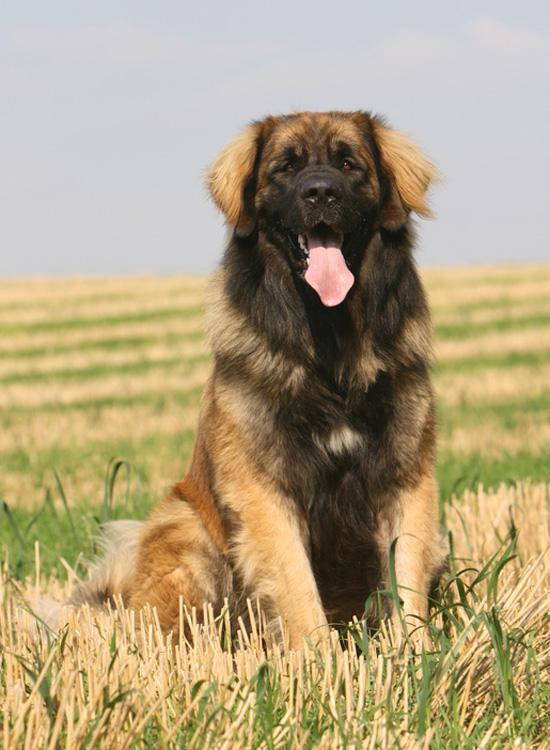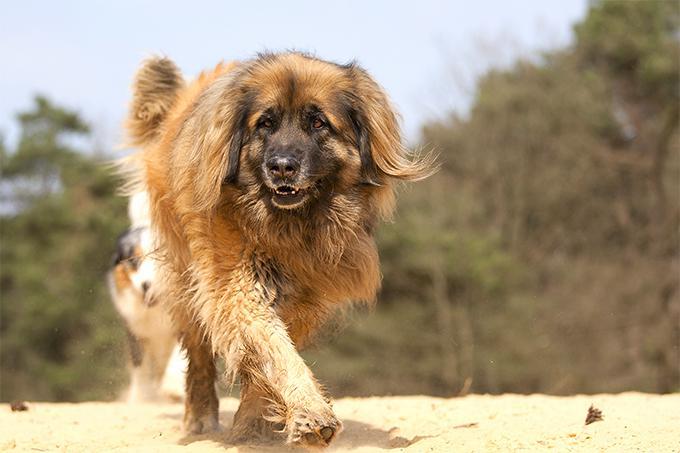The first image is the image on the left, the second image is the image on the right. Considering the images on both sides, is "The sky can be seen behind the dog in the image on the left." valid? Answer yes or no. Yes. The first image is the image on the left, the second image is the image on the right. Analyze the images presented: Is the assertion "The dog in the image on the right is standing outside alone." valid? Answer yes or no. Yes. The first image is the image on the left, the second image is the image on the right. Considering the images on both sides, is "In one image you can only see the dogs head." valid? Answer yes or no. No. The first image is the image on the left, the second image is the image on the right. For the images displayed, is the sentence "A dog with its face turned rightward is standing still on the grass in one image." factually correct? Answer yes or no. No. The first image is the image on the left, the second image is the image on the right. Considering the images on both sides, is "One photo is a closeup of a dog's head and shoulders." valid? Answer yes or no. No. 